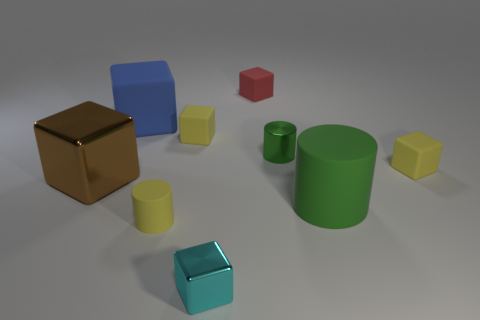How many cylinders are either green metal objects or small red objects?
Your answer should be compact. 1. The red thing is what size?
Keep it short and to the point. Small. There is a brown block; how many cyan things are to the left of it?
Provide a short and direct response. 0. What is the size of the metal block in front of the small yellow object in front of the big brown metal block?
Provide a short and direct response. Small. There is a small shiny object to the right of the small cyan thing; is its shape the same as the brown metallic thing that is to the left of the red matte object?
Make the answer very short. No. What is the shape of the large brown metal thing behind the big matte thing in front of the large matte cube?
Your response must be concise. Cube. There is a matte block that is both in front of the small red cube and to the right of the cyan object; how big is it?
Your answer should be very brief. Small. Is the shape of the big blue object the same as the big thing that is to the right of the small green metallic cylinder?
Your answer should be compact. No. There is a cyan shiny object that is the same shape as the tiny red thing; what is its size?
Your answer should be very brief. Small. There is a metallic cylinder; is it the same color as the big rubber object that is in front of the tiny green metal cylinder?
Keep it short and to the point. Yes. 